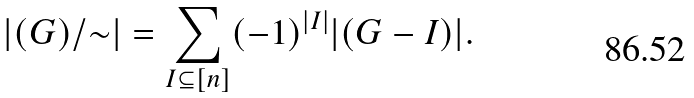<formula> <loc_0><loc_0><loc_500><loc_500>| ( G ) / { \sim } | = \sum _ { I \subseteq [ n ] } ( - 1 ) ^ { | I | } | ( G - I ) | .</formula> 